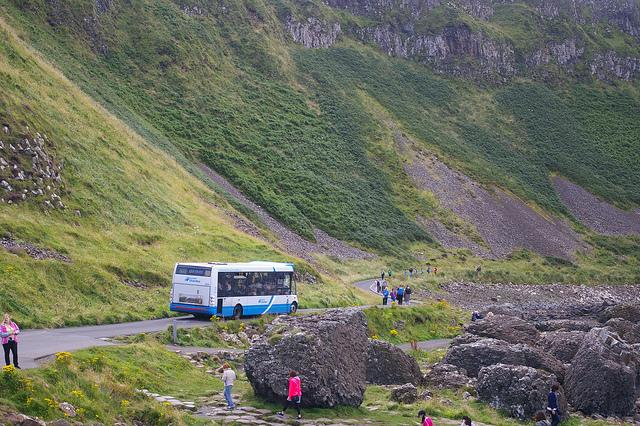What act of nature could potentially physically impede progress on the road? Please explain your reasoning. landslide. Rock and landslides often occur down mountains. 